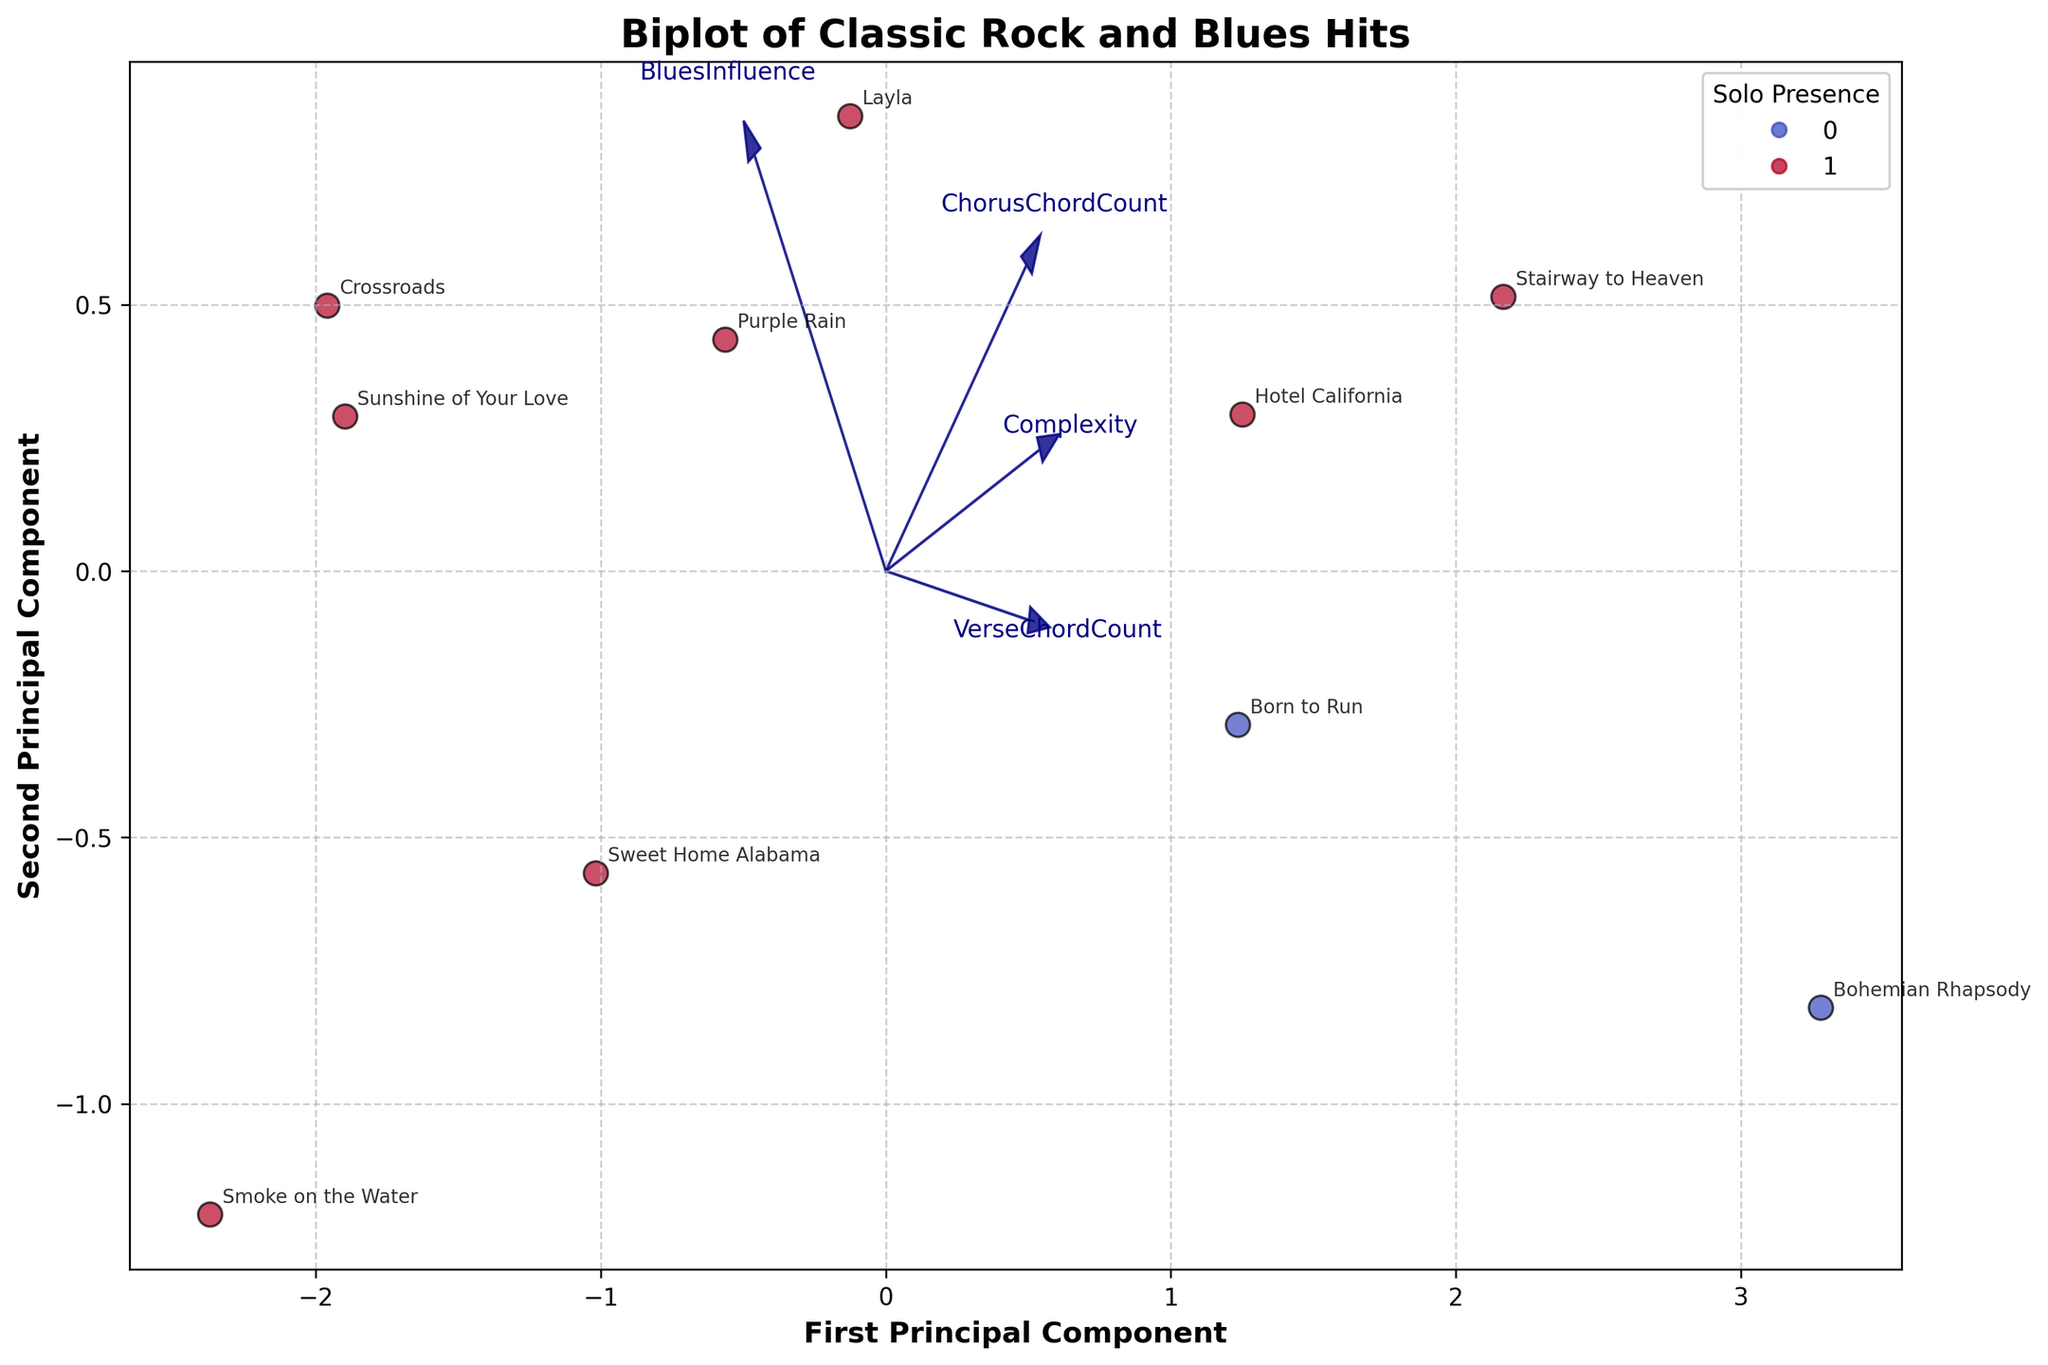Which song has the highest complexity and what are its values on the first and second principal components? By observing the song labels and their positions on the biplot, "Bohemian Rhapsody" has the highest complexity. We then find its coordinates on the plot to determine its values on the first and second principal components.
Answer: Bohemian Rhapsody, [value1], [value2] How many songs have a blues influence higher than 0.6 and also feature a solo? There are two criteria here, blues influence higher than 0.6 and solo presence. First, count all songs that fall into this category by looking at the scatter plot where the color indicates solo presence. Next, check the feature arrows to correlate blues influence values visibly higher than 0.6 and ensure these songs have solo indicators.
Answer: 4 Which feature contributes more to the first principal component, Complexity or Verse Chord Count? To determine this, observe the feature vectors/arrows direction and length along the first principal component axis. The feature with the arrow more aligned and longer along this axis has the greater contribution.
Answer: Complexity Which song appears closest to the origin of the biplot? By inspecting the plot visually, find the song label that is positioned nearest to (0,0) coordinates.
Answer: Smoke on the Water How many songs have verse chord counts greater than chorus chord counts, and are these songs closer or farther from the origin of the biplot on average? Check the data points of each song in the verse and chorus count features. Count the number of songs meeting the verse > chorus criteria. Evaluate their collective proximity by visually interpreting their relative distance from (0,0) on the biplot.
Answer: 1, farther 